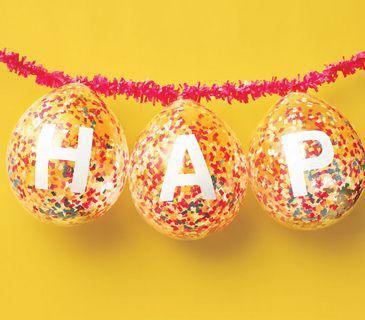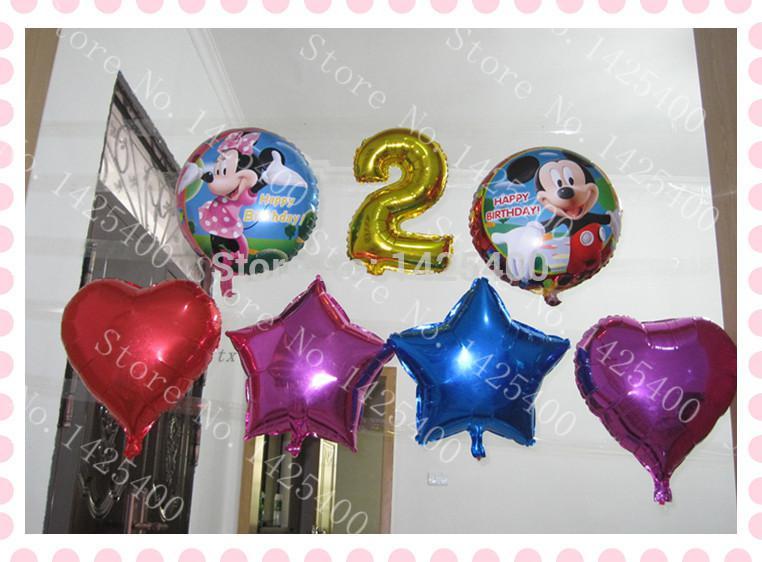The first image is the image on the left, the second image is the image on the right. Examine the images to the left and right. Is the description "One image shows a balloon shaped like the number 2, along with other balloons." accurate? Answer yes or no. Yes. The first image is the image on the left, the second image is the image on the right. Assess this claim about the two images: "One of the balloons is shaped like the number 2.". Correct or not? Answer yes or no. Yes. 